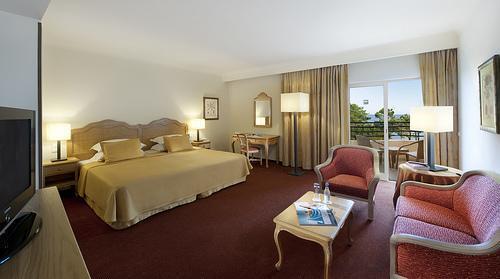How many lamps are in the room?
Give a very brief answer. 4. How many people are in this picture?
Give a very brief answer. 0. How many pillows are on the bed?
Give a very brief answer. 6. 